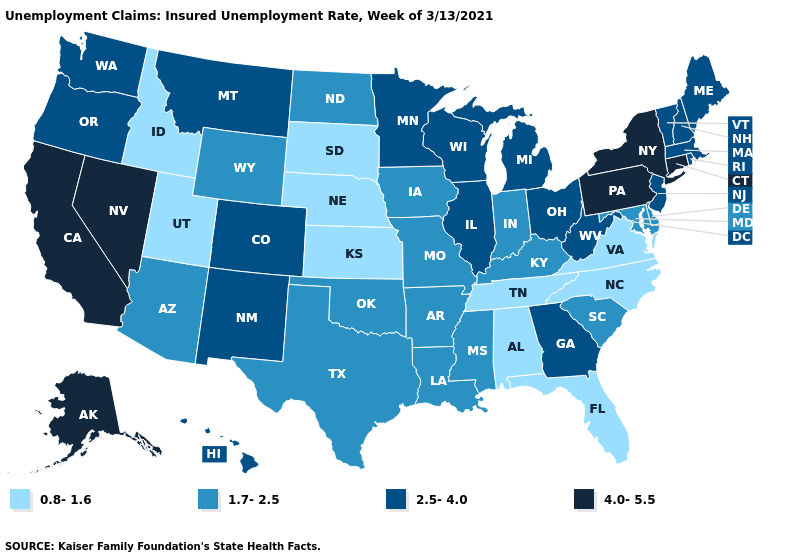How many symbols are there in the legend?
Concise answer only. 4. Name the states that have a value in the range 0.8-1.6?
Write a very short answer. Alabama, Florida, Idaho, Kansas, Nebraska, North Carolina, South Dakota, Tennessee, Utah, Virginia. Name the states that have a value in the range 0.8-1.6?
Answer briefly. Alabama, Florida, Idaho, Kansas, Nebraska, North Carolina, South Dakota, Tennessee, Utah, Virginia. Which states have the highest value in the USA?
Write a very short answer. Alaska, California, Connecticut, Nevada, New York, Pennsylvania. Which states have the lowest value in the West?
Keep it brief. Idaho, Utah. Does Florida have a higher value than Illinois?
Give a very brief answer. No. Among the states that border Idaho , does Nevada have the highest value?
Write a very short answer. Yes. What is the value of Wyoming?
Write a very short answer. 1.7-2.5. How many symbols are there in the legend?
Quick response, please. 4. Name the states that have a value in the range 4.0-5.5?
Give a very brief answer. Alaska, California, Connecticut, Nevada, New York, Pennsylvania. What is the value of Minnesota?
Give a very brief answer. 2.5-4.0. Name the states that have a value in the range 4.0-5.5?
Short answer required. Alaska, California, Connecticut, Nevada, New York, Pennsylvania. What is the value of Vermont?
Give a very brief answer. 2.5-4.0. Does California have the highest value in the USA?
Answer briefly. Yes. Does Rhode Island have a lower value than New Hampshire?
Give a very brief answer. No. 